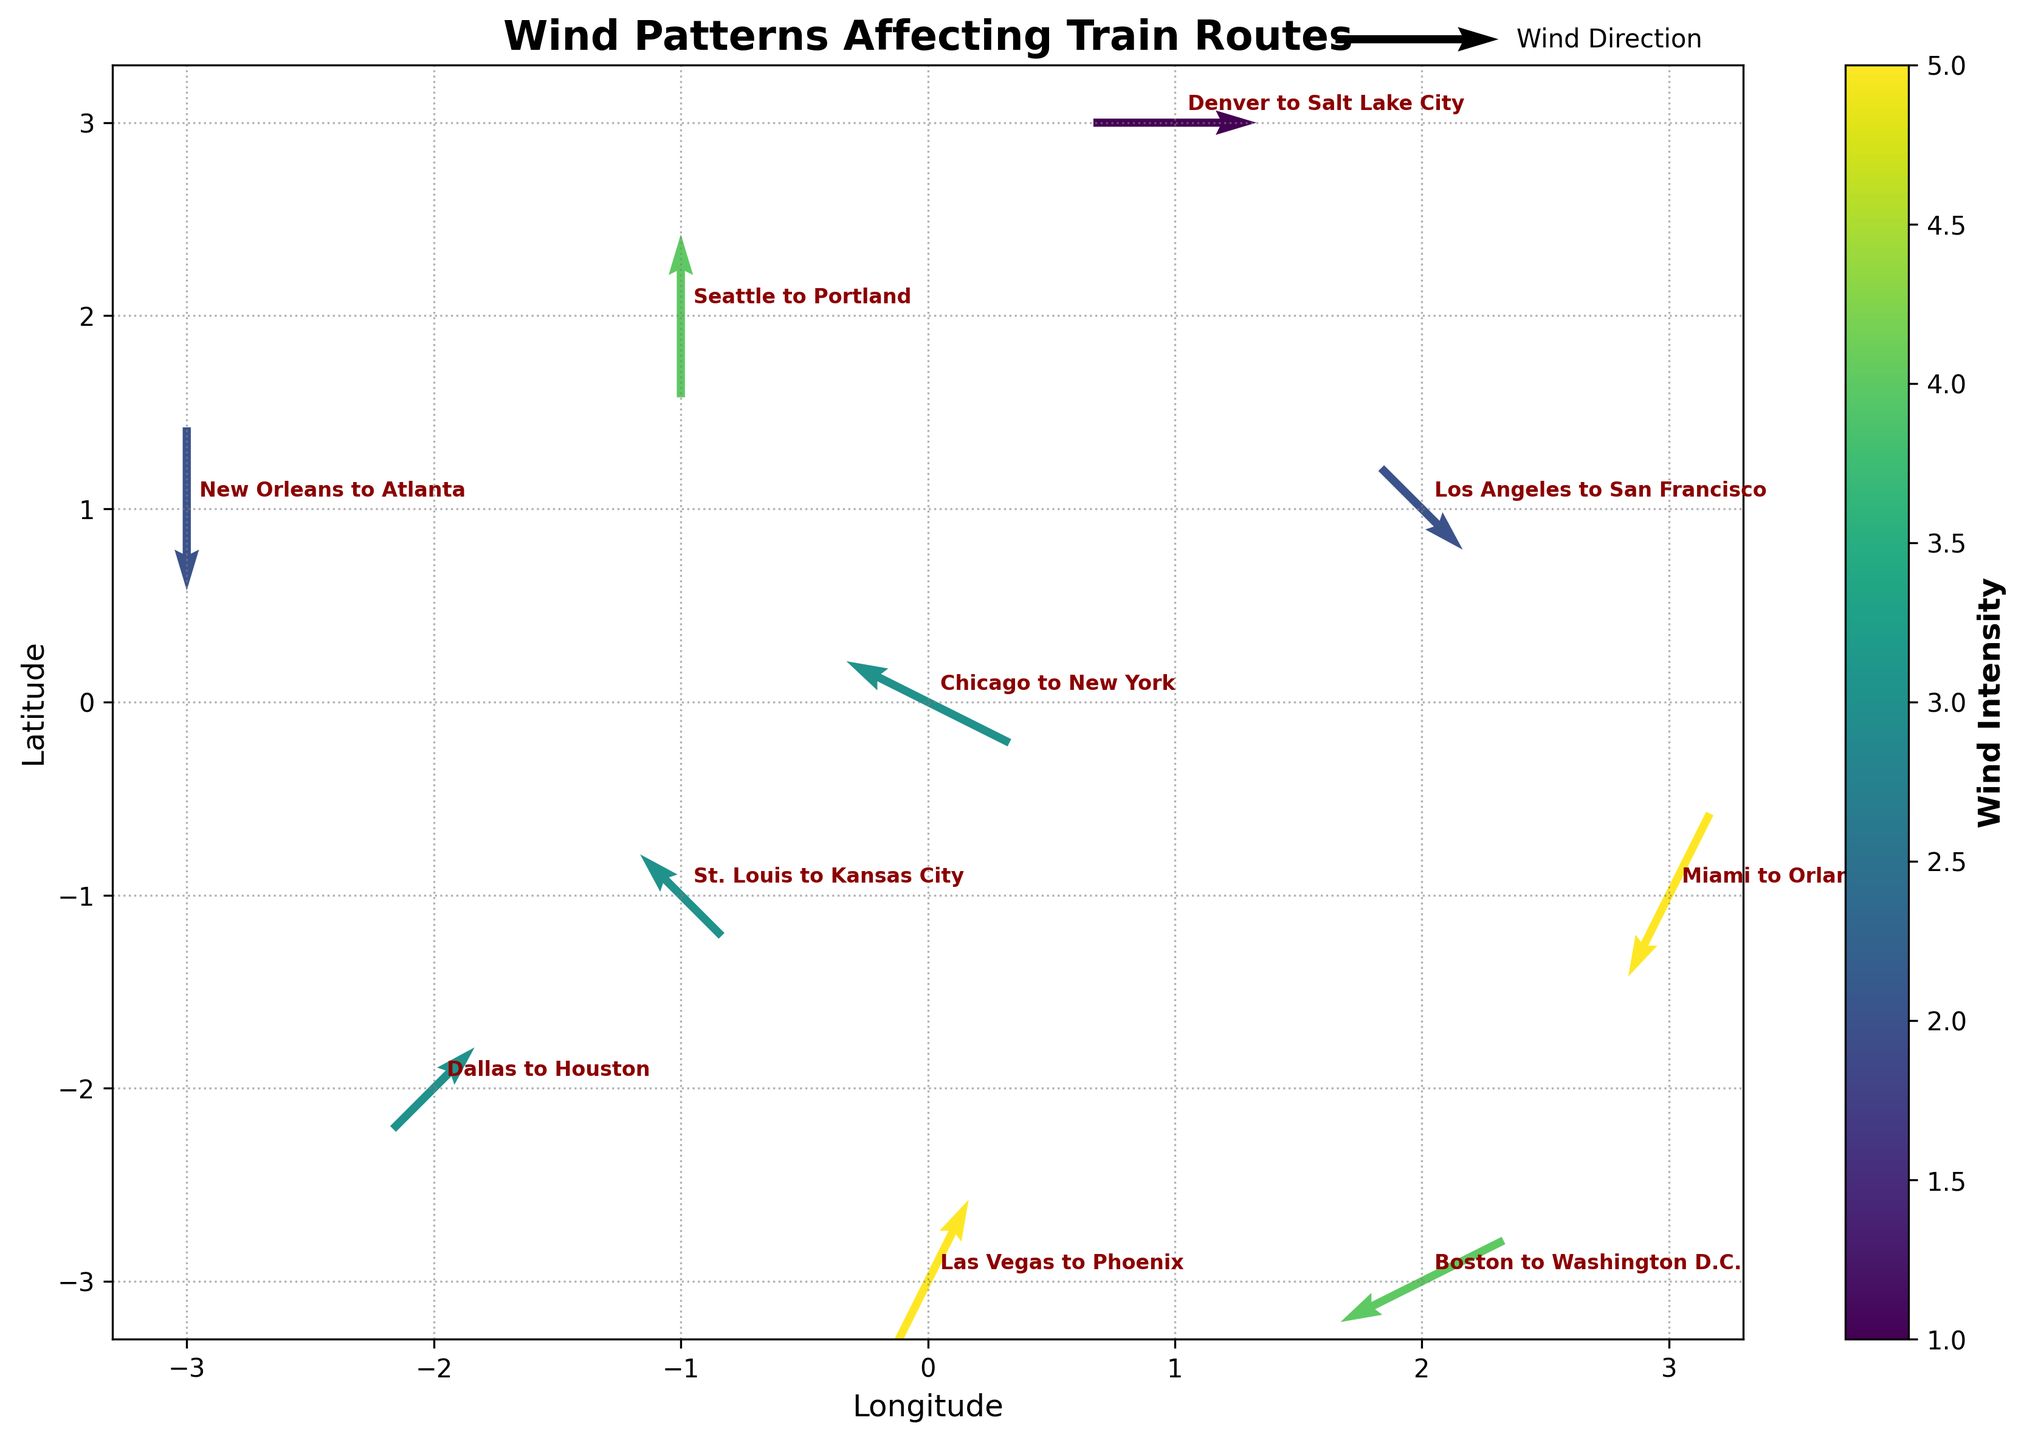What is the title of the plot? The title of the plot is typically located at the top and summarizes what the plot is about. In this case, it should be "Wind Patterns Affecting Train Routes".
Answer: Wind Patterns Affecting Train Routes Which train route experiences the highest wind intensity? To determine this, look for the route corresponding to the darkest (near the highest value) color in the color bar, as it represents the highest wind intensity. The darkest color corresponds to the route "Miami to Orlando".
Answer: Miami to Orlando What is the scale used for the wind direction arrows? The information about the wind direction scale is usually displayed in the legend section of the plot. Here, it’s indicated next to the quiver key, showing that the scale is 2 units.
Answer: 2 units Which arrow represents wind blowing to the northwest? An arrow indicating wind blowing to the northwest will point towards the top-left direction. Locate the arrow pointing in this direction and read its corresponding route. The arrow pointing towards the northwest is for the "Denver to Salt Lake City" route.
Answer: Denver to Salt Lake City What are the longitude and latitude ranges depicted in the plot? Look at the axes to check the range of values. The x-axis represents longitude, and the y-axis represents latitude. The ranges can be derived from the tick marks along both axes. They range from -3 to 3 for both longitude (x) and latitude (y).
Answer: -3 to 3 for both longitude and latitude How many routes are affected by wind patterns in the plot? Count the number of unique arrows present in the quiver plot, as each arrow represents a route being affected by wind. There are 10 unique arrows in the plot.
Answer: 10 What direction is the wind blowing for the Chicago to New York route? Find the arrow corresponding to the route "Chicago to New York" and check where the arrow is pointing. The arrow at (0, 0) points to the top-left, indicating a northwest direction.
Answer: Northwest Compare the wind intensity between "Los Angeles to San Francisco" and "Dallas to Houston". Which route has higher intensity? Identify the color of the arrows corresponding to each route and refer to the color bar for their intensities. "Dallas to Houston" has a higher intensity (3) compared to "Los Angeles to San Francisco" (2).
Answer: Dallas to Houston What is the wind direction for the train route from "Seattle to Portland"? Look at the arrow starting at the coordinates (-1, 2) which represents the "Seattle to Portland" route. The arrow points straight up, indicating a north direction.
Answer: North Which train route has the least wind intensity? To find the route with the least wind intensity, identify the lightest color in the plot and match it to the corresponding route. This route is "Denver to Salt Lake City" with an intensity of 1.
Answer: Denver to Salt Lake City 